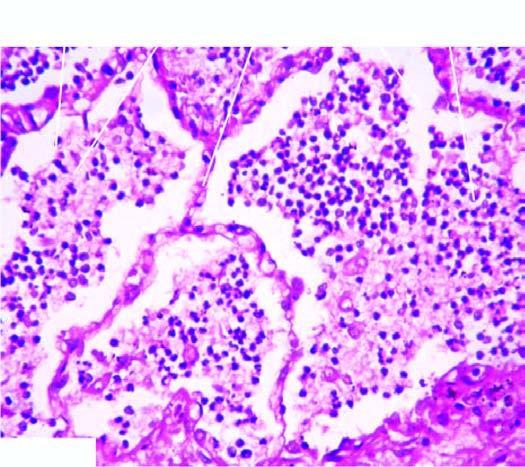what shows grey-brown, firm area of consolidation affecting a lobe?
Answer the question using a single word or phrase. Sectioned surface 